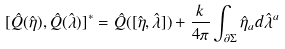Convert formula to latex. <formula><loc_0><loc_0><loc_500><loc_500>[ \hat { Q } ( \hat { \eta } ) , \hat { Q } ( \hat { \lambda } ) ] ^ { * } = \hat { Q } ( [ \hat { \eta } , \hat { \lambda } ] ) + { \frac { k } { 4 \pi } } \int _ { \partial \Sigma } \hat { \eta } _ { a } d \hat { \lambda } ^ { a }</formula> 